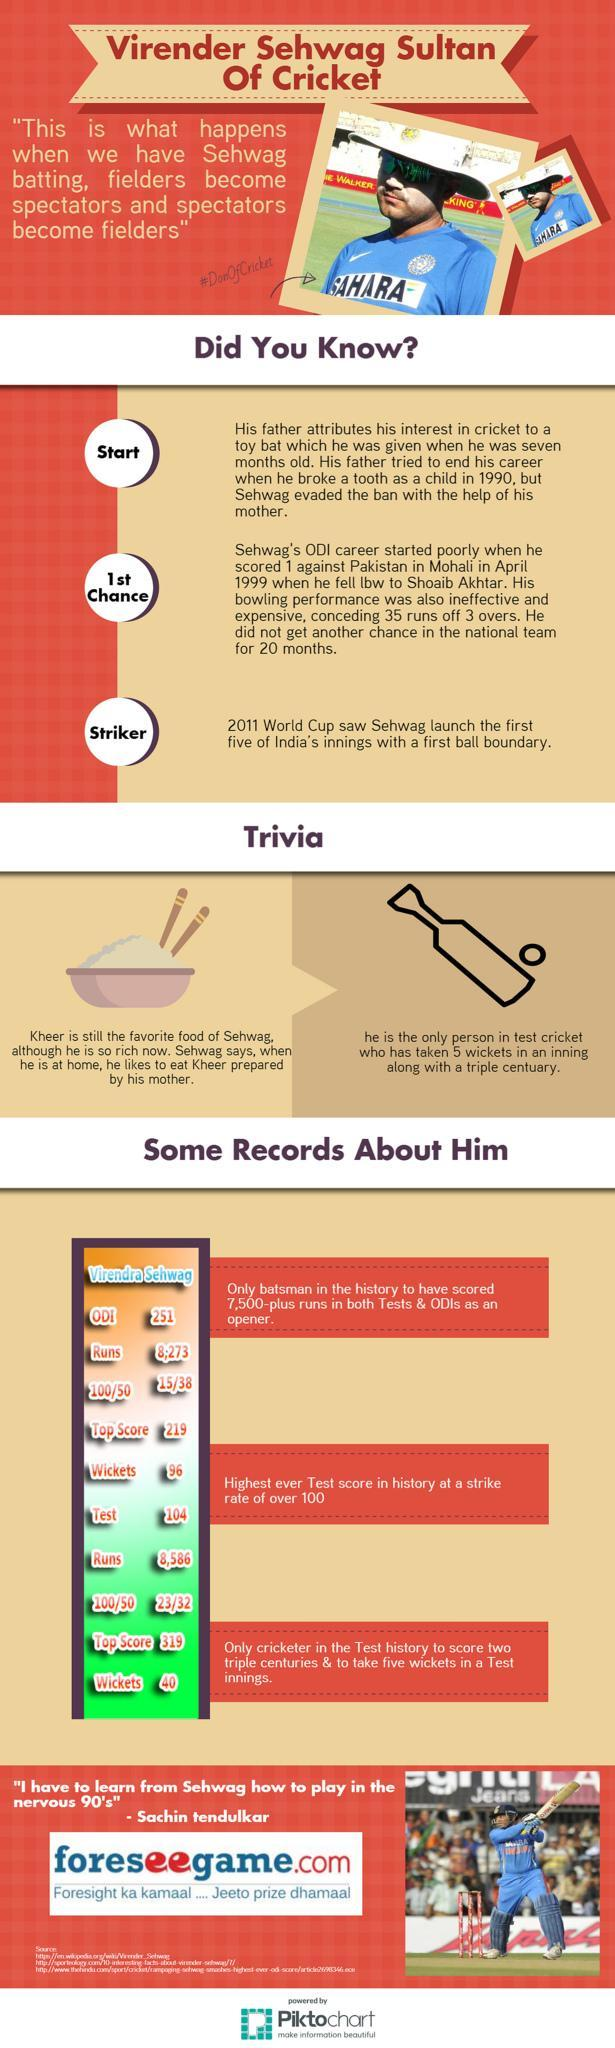How many centuries did Sehwag score in test matches?
Answer the question with a short phrase. 23 How many wickets did Sehwag take in ODI matches? 96 How many 100s did Sehwag score in ODI matches? 15 How many wickets did he take in test matches? 40 In which match did Sehwag make a top score of 319 - ODI or Test? Test In which match did Sehwag make a  top score of 219 - ODI or Test? ODI 